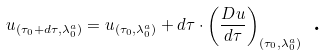Convert formula to latex. <formula><loc_0><loc_0><loc_500><loc_500>u _ { ( \tau _ { 0 } + d \tau , \lambda _ { 0 } ^ { a } ) } = u _ { ( \tau _ { 0 } , \lambda _ { 0 } ^ { a } ) } + d \tau \cdot \left ( \frac { D u } { d \tau } \right ) _ { ( \tau _ { 0 } , \lambda _ { 0 } ^ { a } ) } \text { .}</formula> 